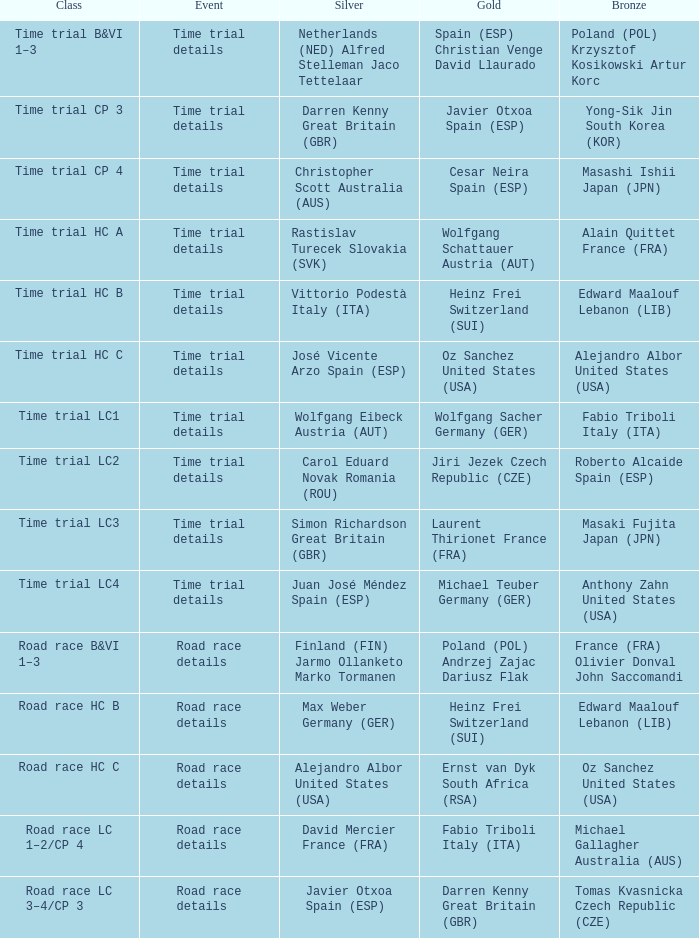What is the event when gold is darren kenny great britain (gbr)? Road race details. 